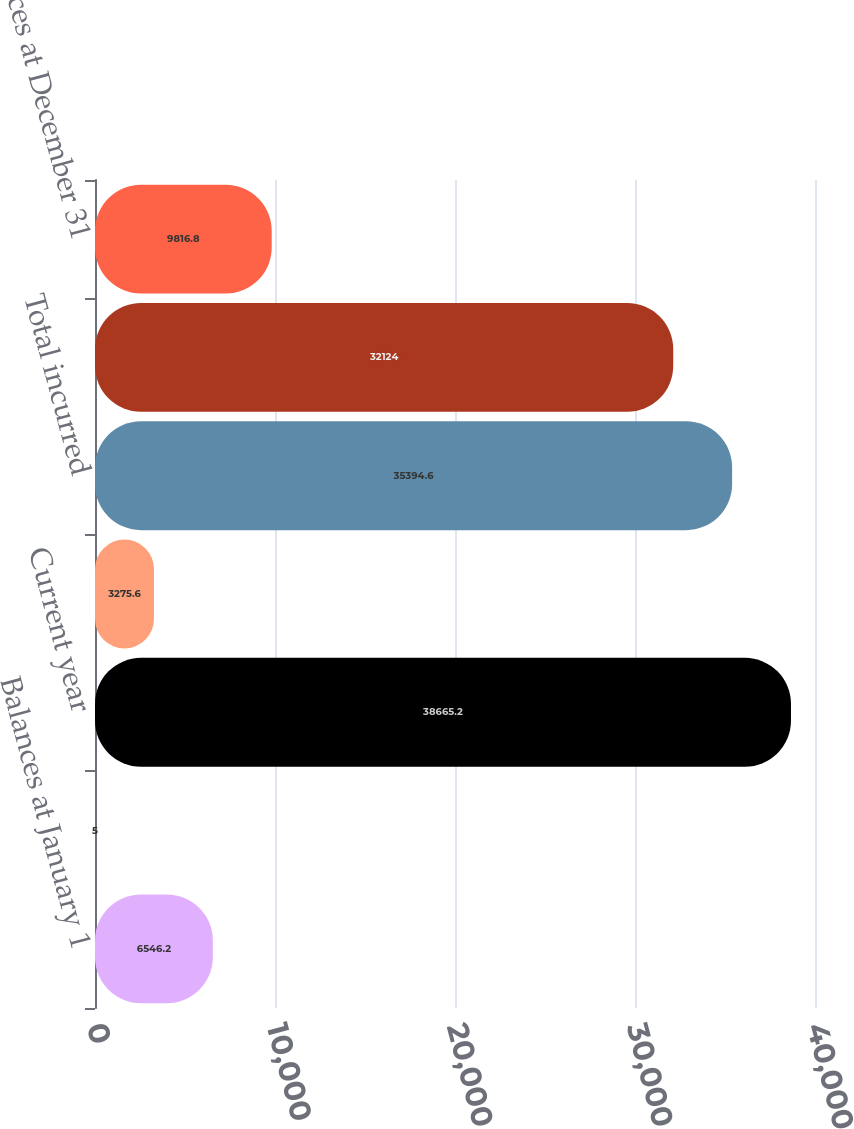Convert chart. <chart><loc_0><loc_0><loc_500><loc_500><bar_chart><fcel>Balances at January 1<fcel>Acquisitions<fcel>Current year<fcel>Prior years<fcel>Total incurred<fcel>Total paid<fcel>Balances at December 31<nl><fcel>6546.2<fcel>5<fcel>38665.2<fcel>3275.6<fcel>35394.6<fcel>32124<fcel>9816.8<nl></chart> 